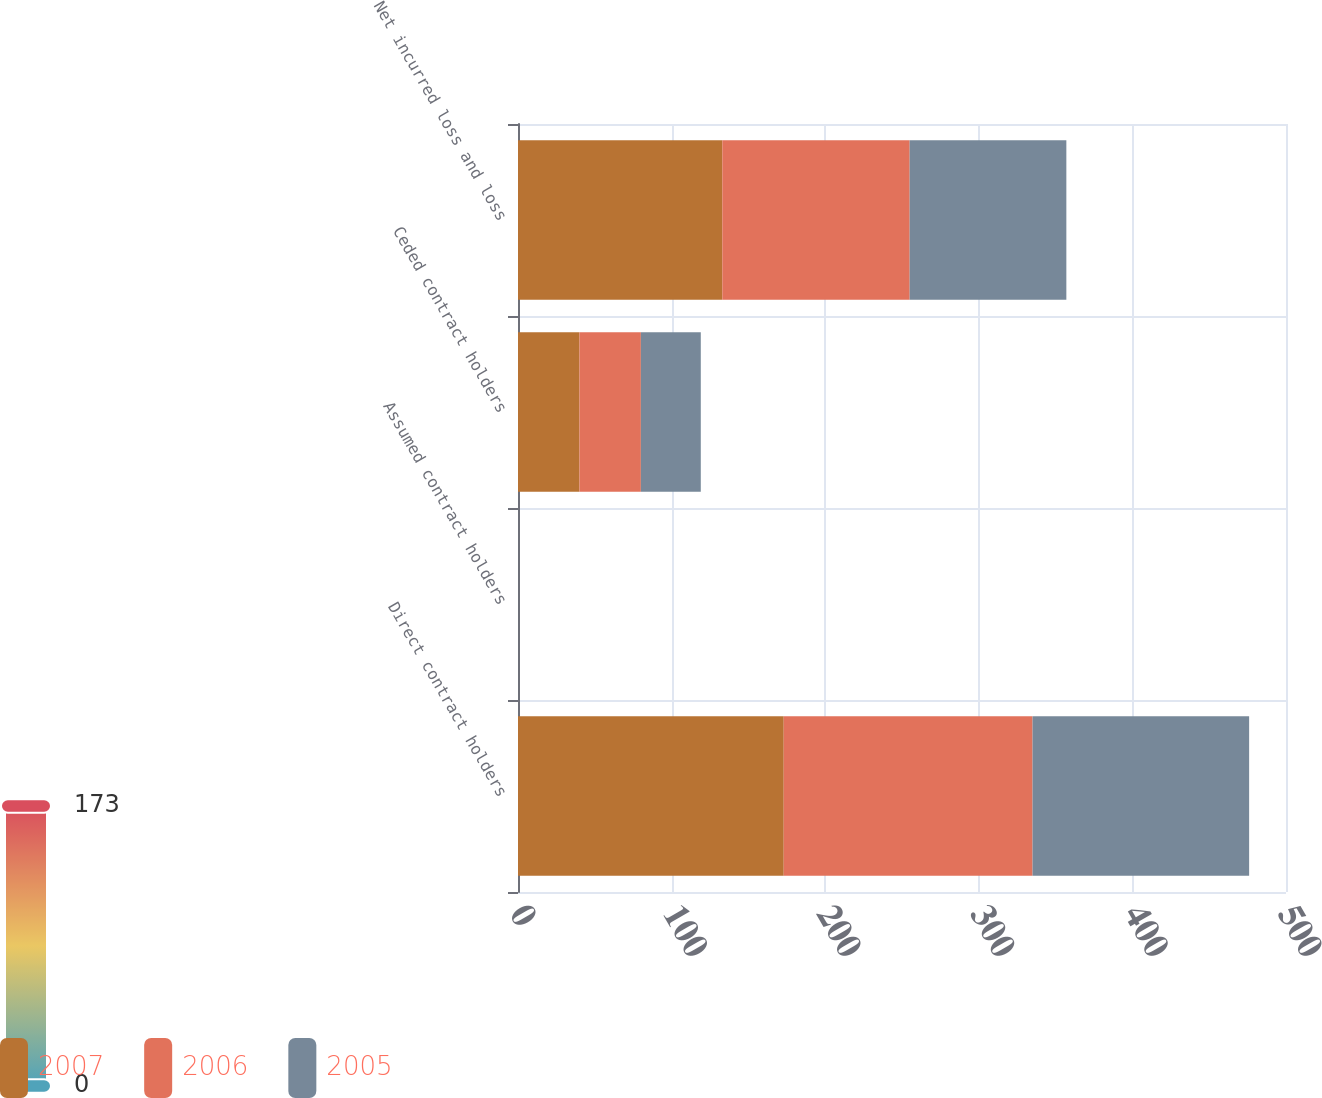<chart> <loc_0><loc_0><loc_500><loc_500><stacked_bar_chart><ecel><fcel>Direct contract holders<fcel>Assumed contract holders<fcel>Ceded contract holders<fcel>Net incurred loss and loss<nl><fcel>2007<fcel>173<fcel>0<fcel>40<fcel>133<nl><fcel>2006<fcel>162<fcel>0<fcel>40<fcel>122<nl><fcel>2005<fcel>141<fcel>0<fcel>39<fcel>102<nl></chart> 